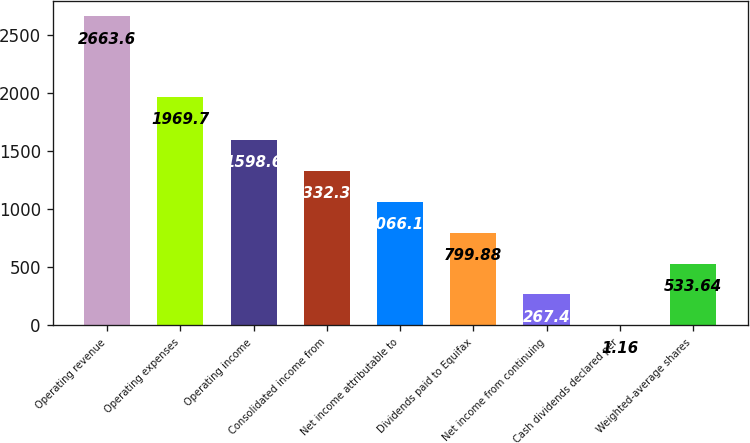Convert chart. <chart><loc_0><loc_0><loc_500><loc_500><bar_chart><fcel>Operating revenue<fcel>Operating expenses<fcel>Operating income<fcel>Consolidated income from<fcel>Net income attributable to<fcel>Dividends paid to Equifax<fcel>Net income from continuing<fcel>Cash dividends declared per<fcel>Weighted-average shares<nl><fcel>2663.6<fcel>1969.7<fcel>1598.6<fcel>1332.36<fcel>1066.12<fcel>799.88<fcel>267.4<fcel>1.16<fcel>533.64<nl></chart> 